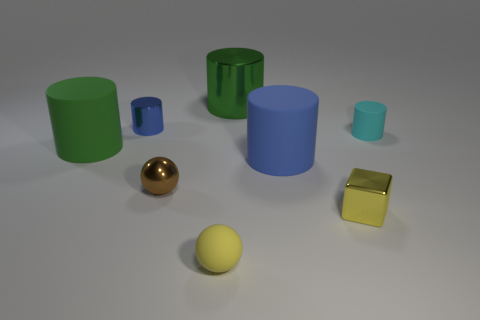There is a large cylinder that is both in front of the small shiny cylinder and right of the large green rubber thing; what color is it?
Provide a short and direct response. Blue. Is the shape of the blue matte object the same as the small brown thing?
Keep it short and to the point. No. The rubber ball that is the same color as the shiny block is what size?
Provide a succinct answer. Small. What shape is the small yellow thing on the right side of the yellow thing that is in front of the yellow shiny object?
Make the answer very short. Cube. There is a tiny brown shiny object; is it the same shape as the small metal object on the right side of the yellow rubber sphere?
Ensure brevity in your answer.  No. The rubber cylinder that is the same size as the green rubber thing is what color?
Make the answer very short. Blue. Is the number of yellow things left of the yellow cube less than the number of small shiny spheres behind the big blue cylinder?
Your response must be concise. No. The big rubber thing that is to the right of the small brown object in front of the tiny rubber thing that is to the right of the cube is what shape?
Provide a succinct answer. Cylinder. Does the block in front of the large green metal thing have the same color as the small object that is behind the small matte cylinder?
Your response must be concise. No. There is a matte thing that is the same color as the block; what is its shape?
Offer a terse response. Sphere. 